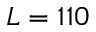<formula> <loc_0><loc_0><loc_500><loc_500>L = 1 1 0</formula> 